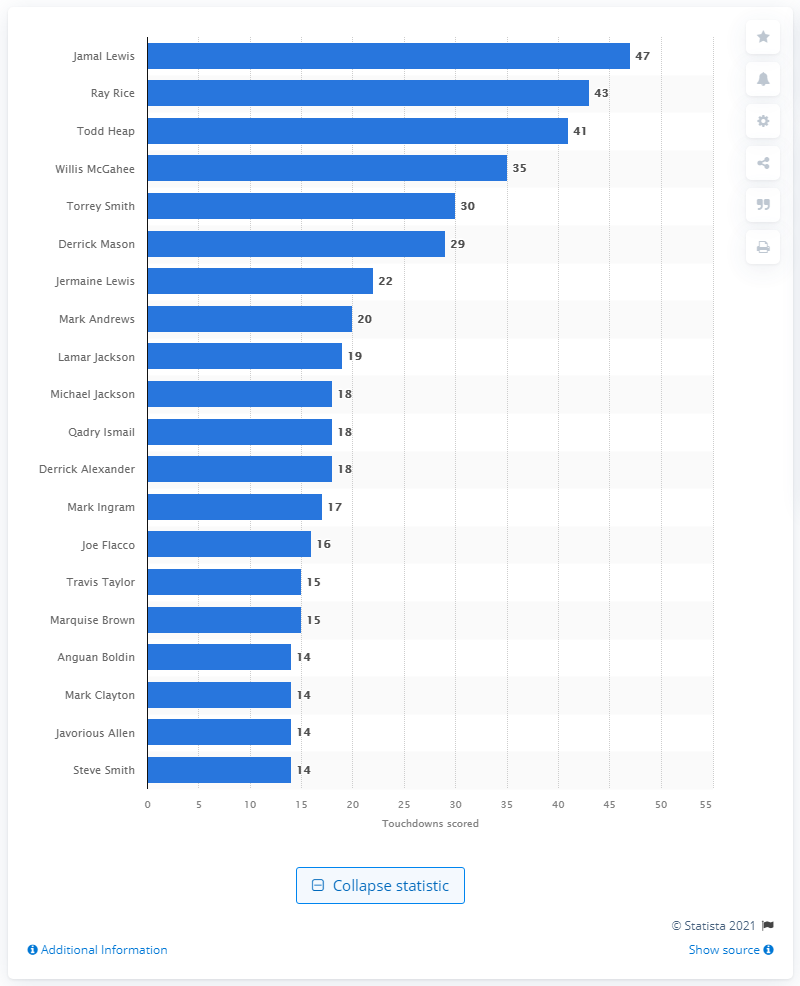Outline some significant characteristics in this image. Jamal Lewis has scored a total of 47 career touchdowns. The career touchdown leader of the Baltimore Ravens is Jamal Lewis. 